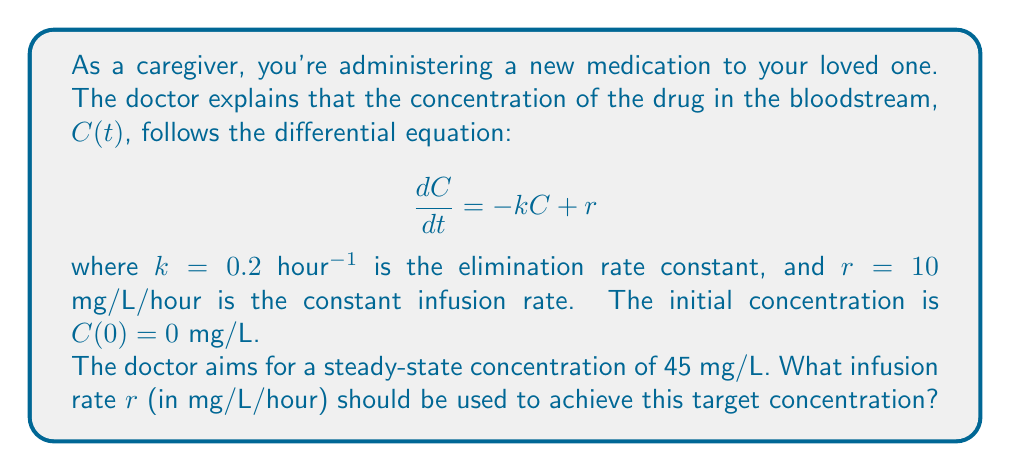Show me your answer to this math problem. Let's approach this step-by-step:

1) At steady-state, the concentration doesn't change over time, so $\frac{dC}{dt} = 0$. 

2) Substituting this into the differential equation:

   $$0 = -kC_{ss} + r$$

   where $C_{ss}$ is the steady-state concentration.

3) Rearranging the equation:

   $$r = kC_{ss}$$

4) We're given that the target steady-state concentration is 45 mg/L and $k = 0.2$ hour$^{-1}$. Let's substitute these values:

   $$r = 0.2 \text{ hour}^{-1} \cdot 45 \text{ mg/L}$$

5) Calculating:

   $$r = 9 \text{ mg/L/hour}$$

Therefore, to achieve a steady-state concentration of 45 mg/L, the infusion rate should be set to 9 mg/L/hour.
Answer: $9 \text{ mg/L/hour}$ 